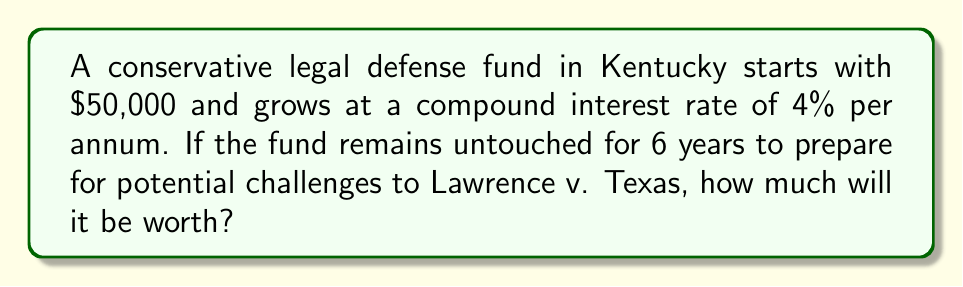Solve this math problem. To solve this problem, we'll use the compound interest formula:

$$A = P(1 + r)^t$$

Where:
$A$ = Final amount
$P$ = Principal (initial investment)
$r$ = Annual interest rate (as a decimal)
$t$ = Time in years

Given:
$P = \$50,000$
$r = 0.04$ (4% expressed as a decimal)
$t = 6$ years

Let's substitute these values into the formula:

$$A = 50,000(1 + 0.04)^6$$

Now, let's calculate step-by-step:

1) First, calculate $(1 + 0.04)^6$:
   $$(1.04)^6 = 1.2653153784$$

2) Multiply this result by the principal:
   $$50,000 \times 1.2653153784 = 63,265.77$$

Therefore, after 6 years, the legal defense fund will be worth $63,265.77.
Answer: $63,265.77 